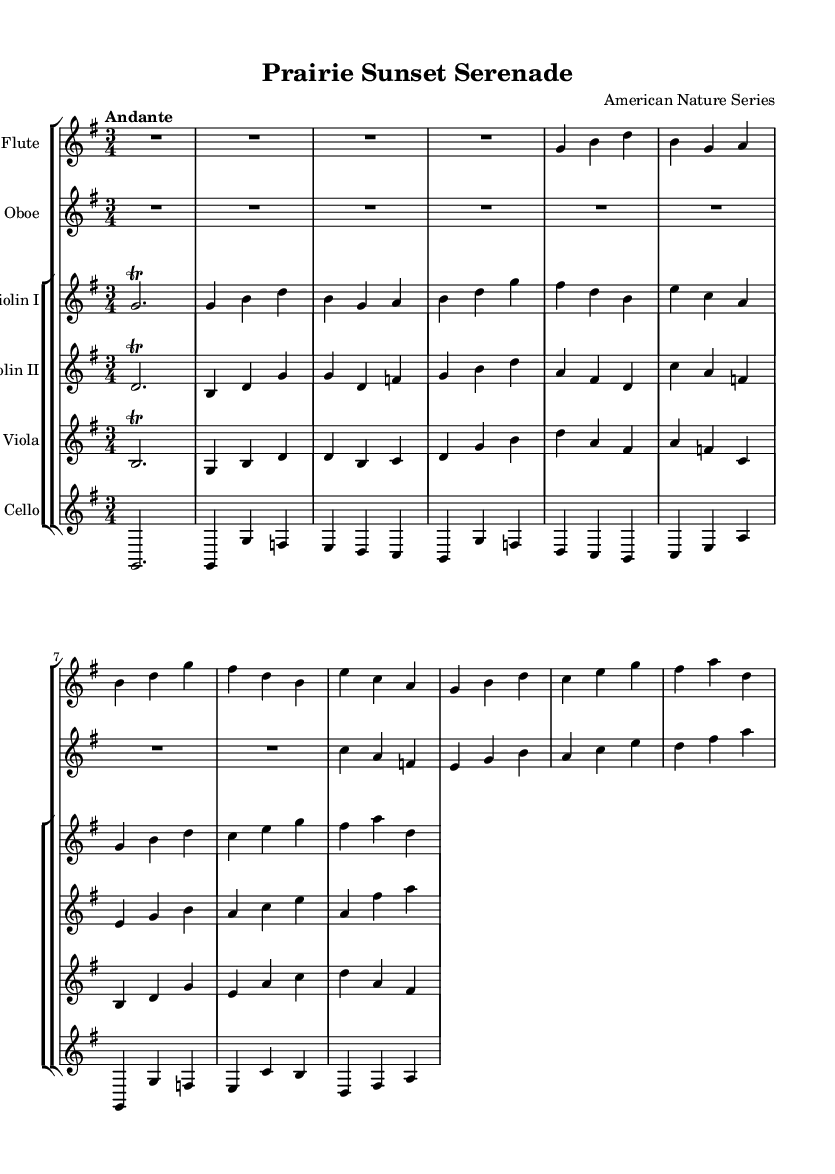What is the title of this piece? The title is indicated at the top of the sheet music in the header section. It clearly states "Prairie Sunset Serenade."
Answer: Prairie Sunset Serenade What is the time signature of this music? The time signature is present in the global settings of the code, which defines how many beats are in each measure. Here, it is marked as 3/4.
Answer: 3/4 What is the tempo marking for this piece? The tempo marking is described in the global section, which states "Andante," indicating a moderate pace.
Answer: Andante What instruments are used in this composition? The instruments are listed in the score section of the code where each staff is labeled with the instrument name. The instruments include Flute, Oboe, Violin I, Violin II, Viola, and Cello.
Answer: Flute, Oboe, Violin I, Violin II, Viola, Cello How many themes are present in this piece? By analyzing the various sections labeled as "Theme A" and "Theme B," we can count that there are two distinct themes.
Answer: Two What is the key signature of this music? The key signature is defined in the global settings of the code as G major, which has one sharp (F#).
Answer: G major Which instrument has a trill at the beginning? The introduction of the flute and both violins (Violin I and Violin II) are indicated with trills, while the other instruments have different notations.
Answer: Flute, Violin I, Violin II 